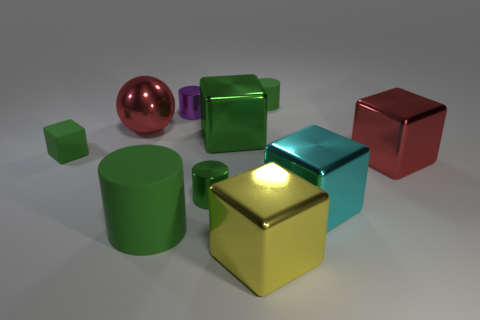How big is the green block to the right of the purple cylinder?
Offer a terse response. Large. What number of things are red cylinders or small things that are to the left of the large rubber cylinder?
Give a very brief answer. 1. How many other things are there of the same size as the metal ball?
Give a very brief answer. 5. What material is the large cyan thing that is the same shape as the large yellow thing?
Make the answer very short. Metal. Are there more big cyan metal objects that are left of the large cyan block than green blocks?
Your answer should be very brief. No. Is there any other thing of the same color as the tiny matte cylinder?
Make the answer very short. Yes. What is the shape of the large cyan object that is the same material as the large yellow object?
Keep it short and to the point. Cube. Is the material of the green cylinder that is behind the red shiny block the same as the big cyan object?
Your answer should be compact. No. There is a tiny shiny thing that is the same color as the tiny cube; what is its shape?
Ensure brevity in your answer.  Cylinder. Is the color of the big cube that is behind the small cube the same as the cube right of the cyan metallic thing?
Make the answer very short. No. 